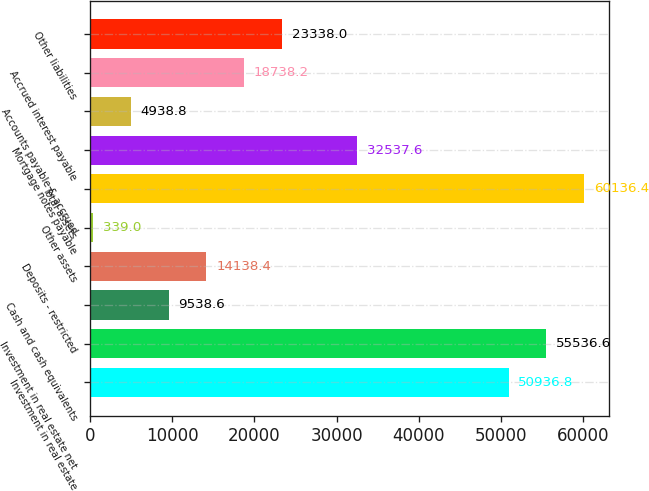Convert chart to OTSL. <chart><loc_0><loc_0><loc_500><loc_500><bar_chart><fcel>Investment in real estate<fcel>Investment in real estate net<fcel>Cash and cash equivalents<fcel>Deposits - restricted<fcel>Other assets<fcel>Total assets<fcel>Mortgage notes payable<fcel>Accounts payable & accrued<fcel>Accrued interest payable<fcel>Other liabilities<nl><fcel>50936.8<fcel>55536.6<fcel>9538.6<fcel>14138.4<fcel>339<fcel>60136.4<fcel>32537.6<fcel>4938.8<fcel>18738.2<fcel>23338<nl></chart> 